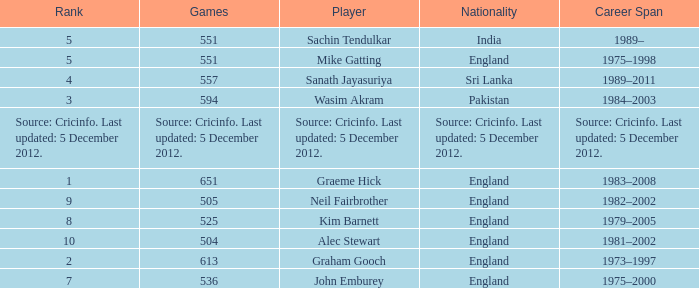Could you parse the entire table as a dict? {'header': ['Rank', 'Games', 'Player', 'Nationality', 'Career Span'], 'rows': [['5', '551', 'Sachin Tendulkar', 'India', '1989–'], ['5', '551', 'Mike Gatting', 'England', '1975–1998'], ['4', '557', 'Sanath Jayasuriya', 'Sri Lanka', '1989–2011'], ['3', '594', 'Wasim Akram', 'Pakistan', '1984–2003'], ['Source: Cricinfo. Last updated: 5 December 2012.', 'Source: Cricinfo. Last updated: 5 December 2012.', 'Source: Cricinfo. Last updated: 5 December 2012.', 'Source: Cricinfo. Last updated: 5 December 2012.', 'Source: Cricinfo. Last updated: 5 December 2012.'], ['1', '651', 'Graeme Hick', 'England', '1983–2008'], ['9', '505', 'Neil Fairbrother', 'England', '1982–2002'], ['8', '525', 'Kim Barnett', 'England', '1979–2005'], ['10', '504', 'Alec Stewart', 'England', '1981–2002'], ['2', '613', 'Graham Gooch', 'England', '1973–1997'], ['7', '536', 'John Emburey', 'England', '1975–2000']]} What is Graham Gooch's nationality? England. 